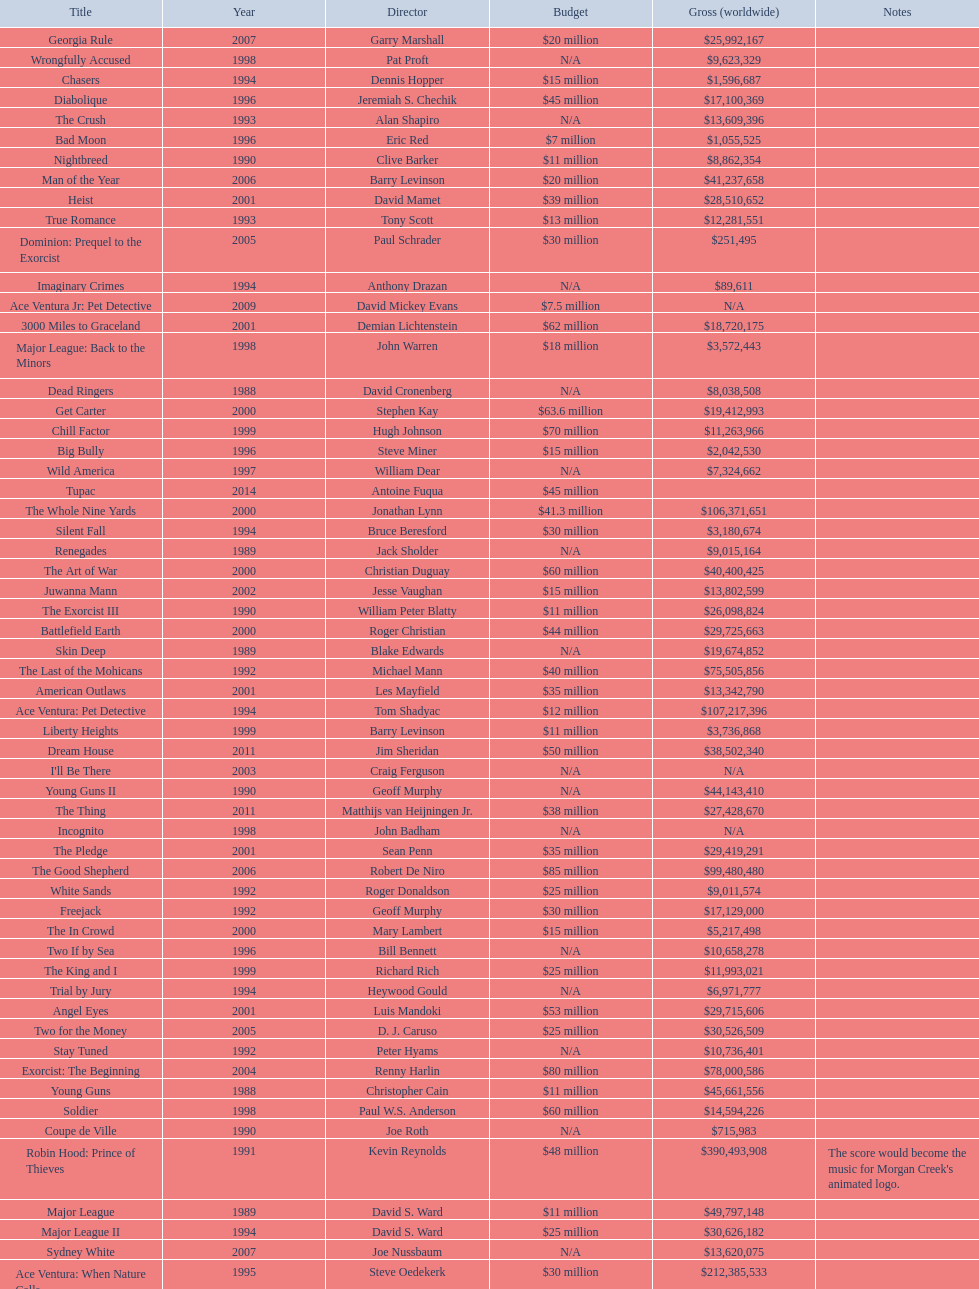After young guns, what was the next movie with the exact same budget? Major League. 